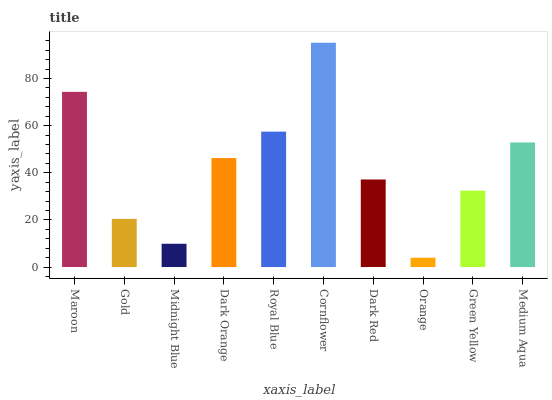Is Orange the minimum?
Answer yes or no. Yes. Is Cornflower the maximum?
Answer yes or no. Yes. Is Gold the minimum?
Answer yes or no. No. Is Gold the maximum?
Answer yes or no. No. Is Maroon greater than Gold?
Answer yes or no. Yes. Is Gold less than Maroon?
Answer yes or no. Yes. Is Gold greater than Maroon?
Answer yes or no. No. Is Maroon less than Gold?
Answer yes or no. No. Is Dark Orange the high median?
Answer yes or no. Yes. Is Dark Red the low median?
Answer yes or no. Yes. Is Midnight Blue the high median?
Answer yes or no. No. Is Green Yellow the low median?
Answer yes or no. No. 